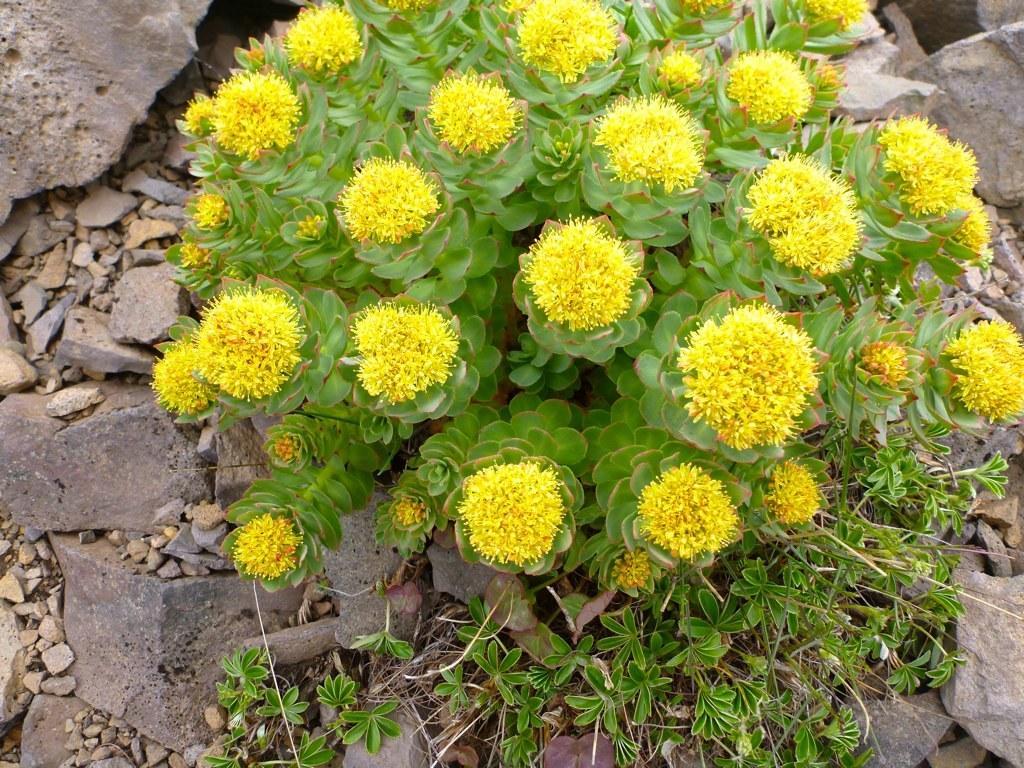Could you give a brief overview of what you see in this image? In the image in the center we can see one plant and few yellow color flowers. In the background we can see stones and grass. 